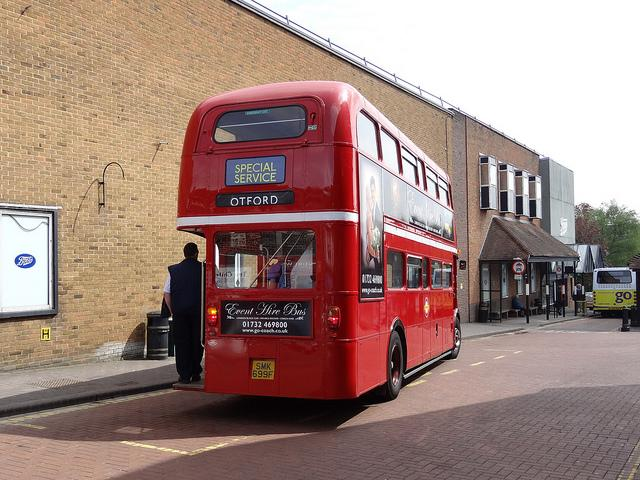What word is written before service? special 